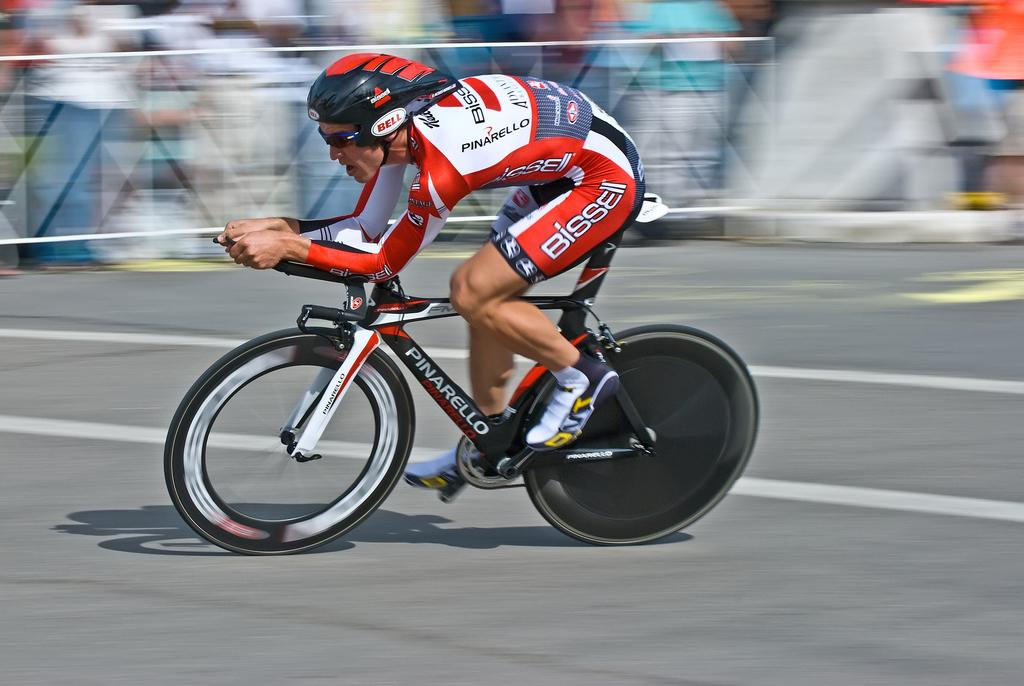Who is the main subject in the image? There is a man in the image. What is the man doing in the image? The man is riding a cycle. What is the man wearing in the image? The man is wearing a racing costume. Can you describe the background of the image? The background of the image is blurred. What type of knife is the man holding in the image? There is no knife present in the image; the man is riding a cycle and wearing a racing costume. 